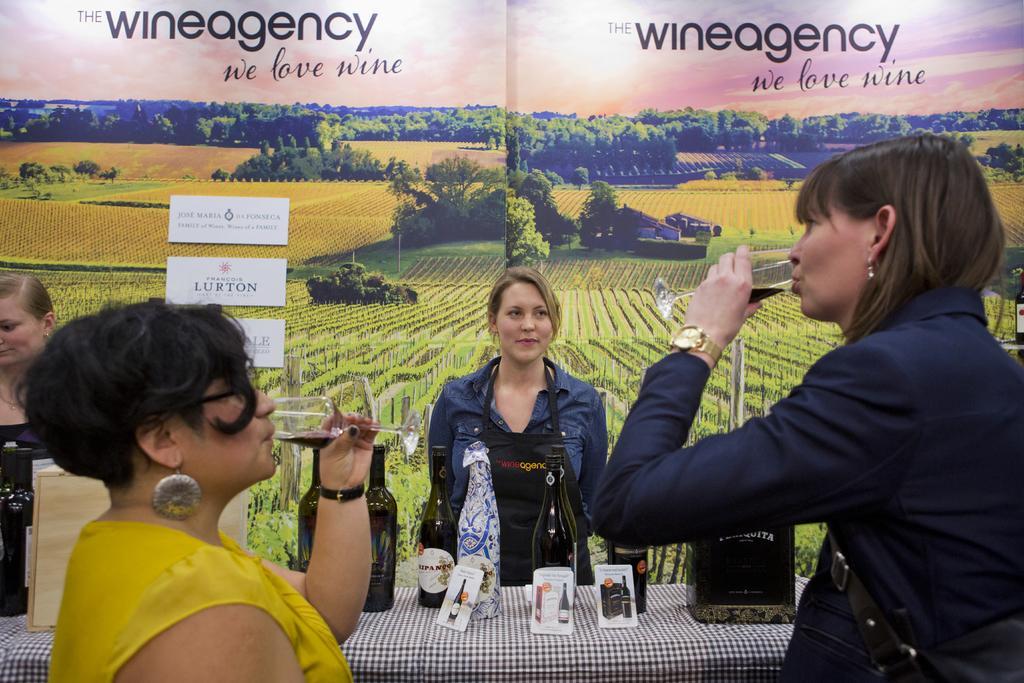Describe this image in one or two sentences. in the picture we can see different women standing and drinking some liquid holding glasses in there hands,we can also see some bottles on the table we can see the beautiful scenery. 